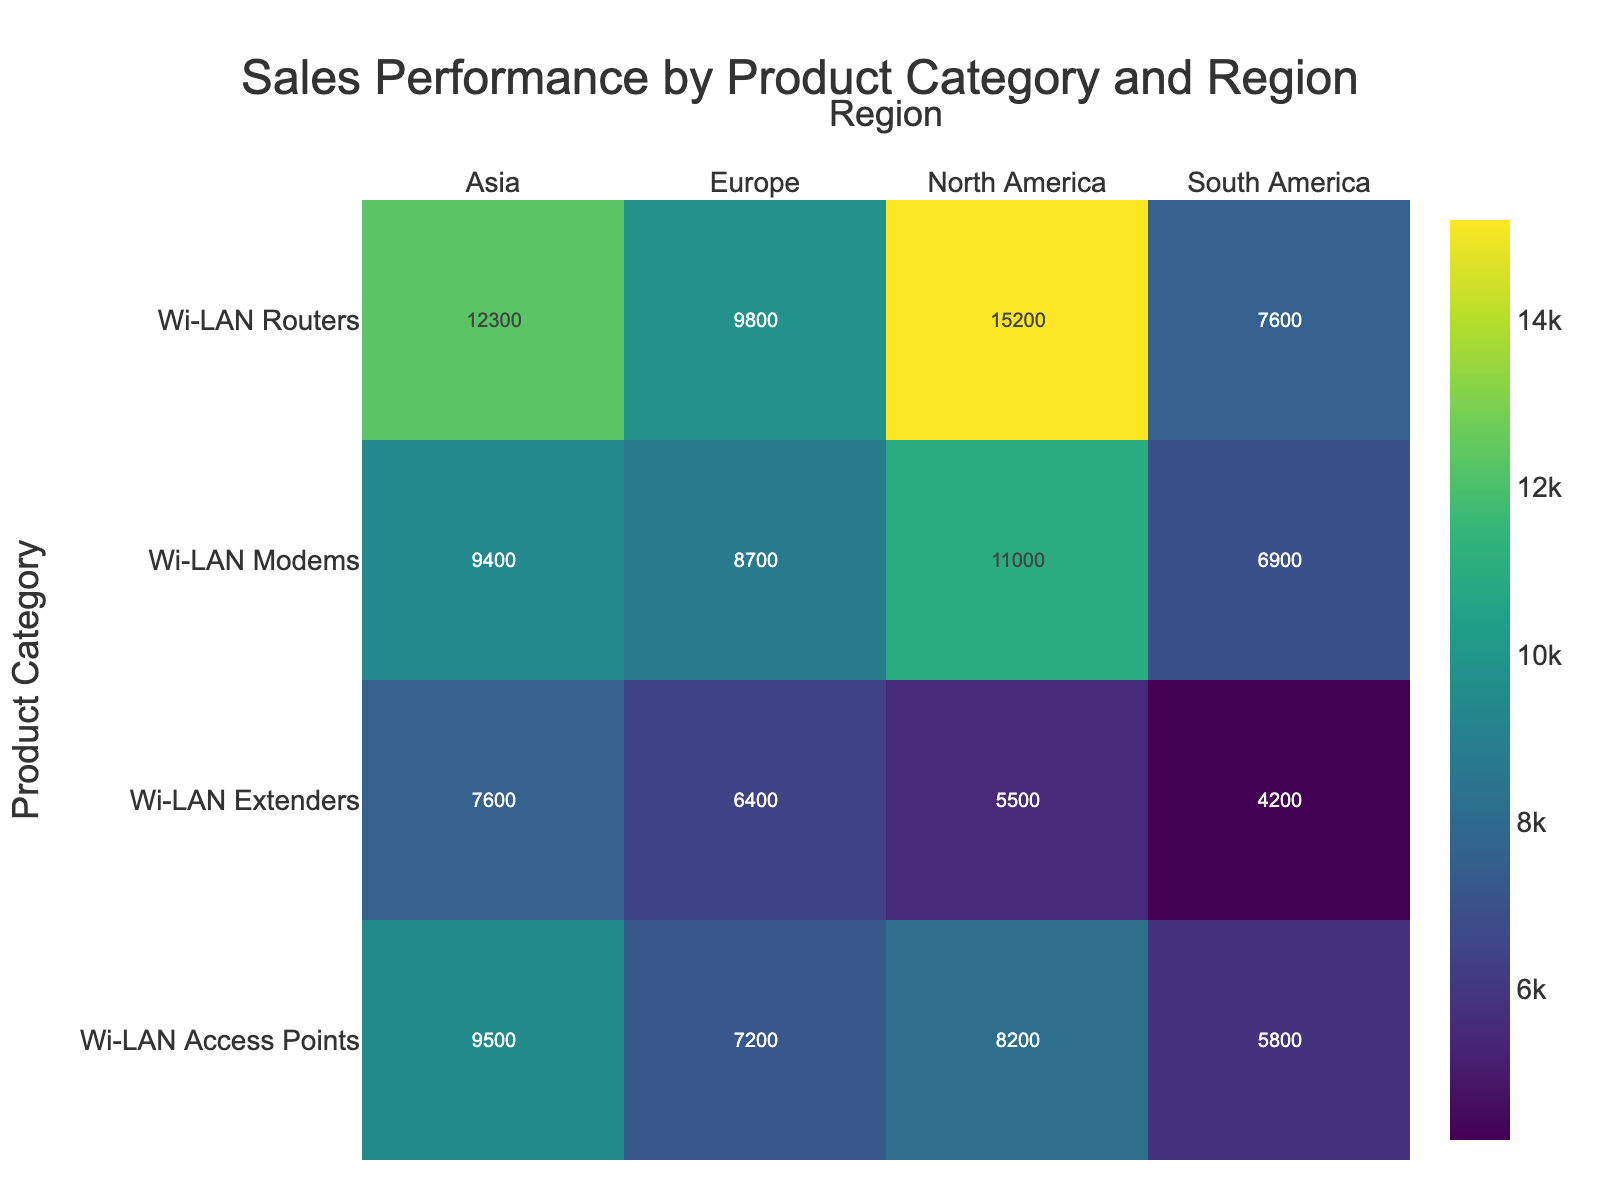What is the title of the heatmap? The title is usually positioned at the top center of the figure. In this case, looking at the heatmap, the title text is 'Sales Performance by Product Category and Region'.
Answer: Sales Performance by Product Category and Region What is the range of sales performance values for Wi-LAN Routers? To find the range, identify the highest and lowest sales performance values for Wi-LAN Routers. The values are 15,200 (North America), 9,800 (Europe), 12,300 (Asia), and 7,600 (South America). The range is calculated by subtracting the lowest value from the highest value.
Answer: 7,600 to 15,200 Which region has the lowest sales performance for Wi-LAN Extenders? Focus on the Wi-LAN Extenders row. Observe the sales performance values for each region: North America (5,500), Europe (6,400), Asia (7,600), and South America (4,200). The smallest value is in South America.
Answer: South America Which product category has the highest sales performance in Asia? Scan through the Asia column to compare the sales performance values for all product categories. The values are Wi-LAN Routers (12,300), Wi-LAN Modems (9,400), Wi-LAN Access Points (9,500), and Wi-LAN Extenders (7,600). The highest value is for Wi-LAN Routers.
Answer: Wi-LAN Routers What is the sum of sales performance for Wi-LAN Modems across all regions? Add the sales performance values for Wi-LAN Modems in each region: North America (11,000), Europe (8,700), Asia (9,400), and South America (6,900). The sum is calculated as 11,000 + 8,700 + 9,400 + 6,900 = 36,000.
Answer: 36,000 Is the average sales performance for Wi-LAN Access Points higher or lower than that for Wi-LAN Routers? First, calculate the average sales performance for each category. Wi-LAN Access Points: (8,200 + 7,200 + 9,500 + 5,800) / 4 = 7,675. Wi-LAN Routers: (15,200 + 9,800 + 12,300 + 7,600) / 4 = 11,225. Compare the two averages: 7,675 is lower than 11,225.
Answer: Lower Which product category has the most consistent sales performance across all regions? To determine consistency, evaluate the spread of the sales performance values within each category. The standard deviation or range can be used as an indicator. Wi-LAN Routers (range = 15,200 - 7,600), Wi-LAN Modems (range = 11,000 - 6,900), Wi-LAN Access Points (range = 9,500 - 5,800), and Wi-LAN Extenders (range = 7,600 - 4,200). Wi-LAN Access Points have the smallest range, indicating the most consistency.
Answer: Wi-LAN Access Points 